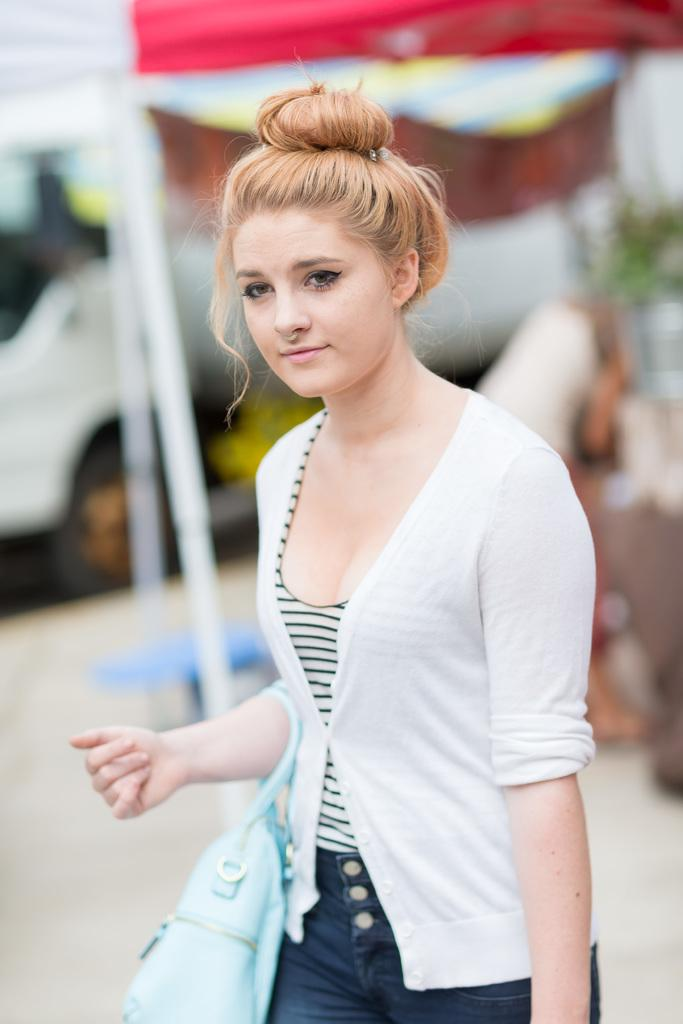Who is the main subject in the foreground of the image? There is a woman in the foreground of the image. What is the woman doing in the image? The woman is standing in the image. What is the woman carrying in the image? The woman is carrying a bag in the image. What can be seen in the background of the image? There is a rent and a vehicle in the background of the image. What type of addition can be seen in the image? There is no addition present in the image. What thing is being expanded in the image? There is no thing being expanded in the image. 